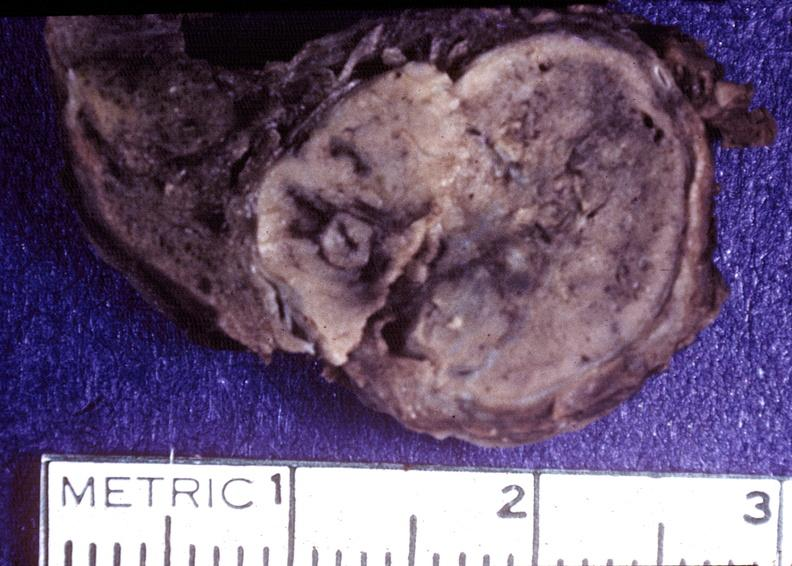what does this image show?
Answer the question using a single word or phrase. Thyroid 